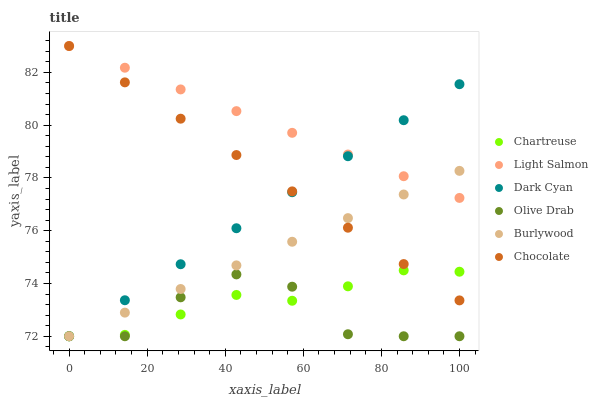Does Olive Drab have the minimum area under the curve?
Answer yes or no. Yes. Does Light Salmon have the maximum area under the curve?
Answer yes or no. Yes. Does Burlywood have the minimum area under the curve?
Answer yes or no. No. Does Burlywood have the maximum area under the curve?
Answer yes or no. No. Is Dark Cyan the smoothest?
Answer yes or no. Yes. Is Olive Drab the roughest?
Answer yes or no. Yes. Is Burlywood the smoothest?
Answer yes or no. No. Is Burlywood the roughest?
Answer yes or no. No. Does Burlywood have the lowest value?
Answer yes or no. Yes. Does Chocolate have the lowest value?
Answer yes or no. No. Does Chocolate have the highest value?
Answer yes or no. Yes. Does Burlywood have the highest value?
Answer yes or no. No. Is Olive Drab less than Light Salmon?
Answer yes or no. Yes. Is Light Salmon greater than Chartreuse?
Answer yes or no. Yes. Does Dark Cyan intersect Olive Drab?
Answer yes or no. Yes. Is Dark Cyan less than Olive Drab?
Answer yes or no. No. Is Dark Cyan greater than Olive Drab?
Answer yes or no. No. Does Olive Drab intersect Light Salmon?
Answer yes or no. No. 